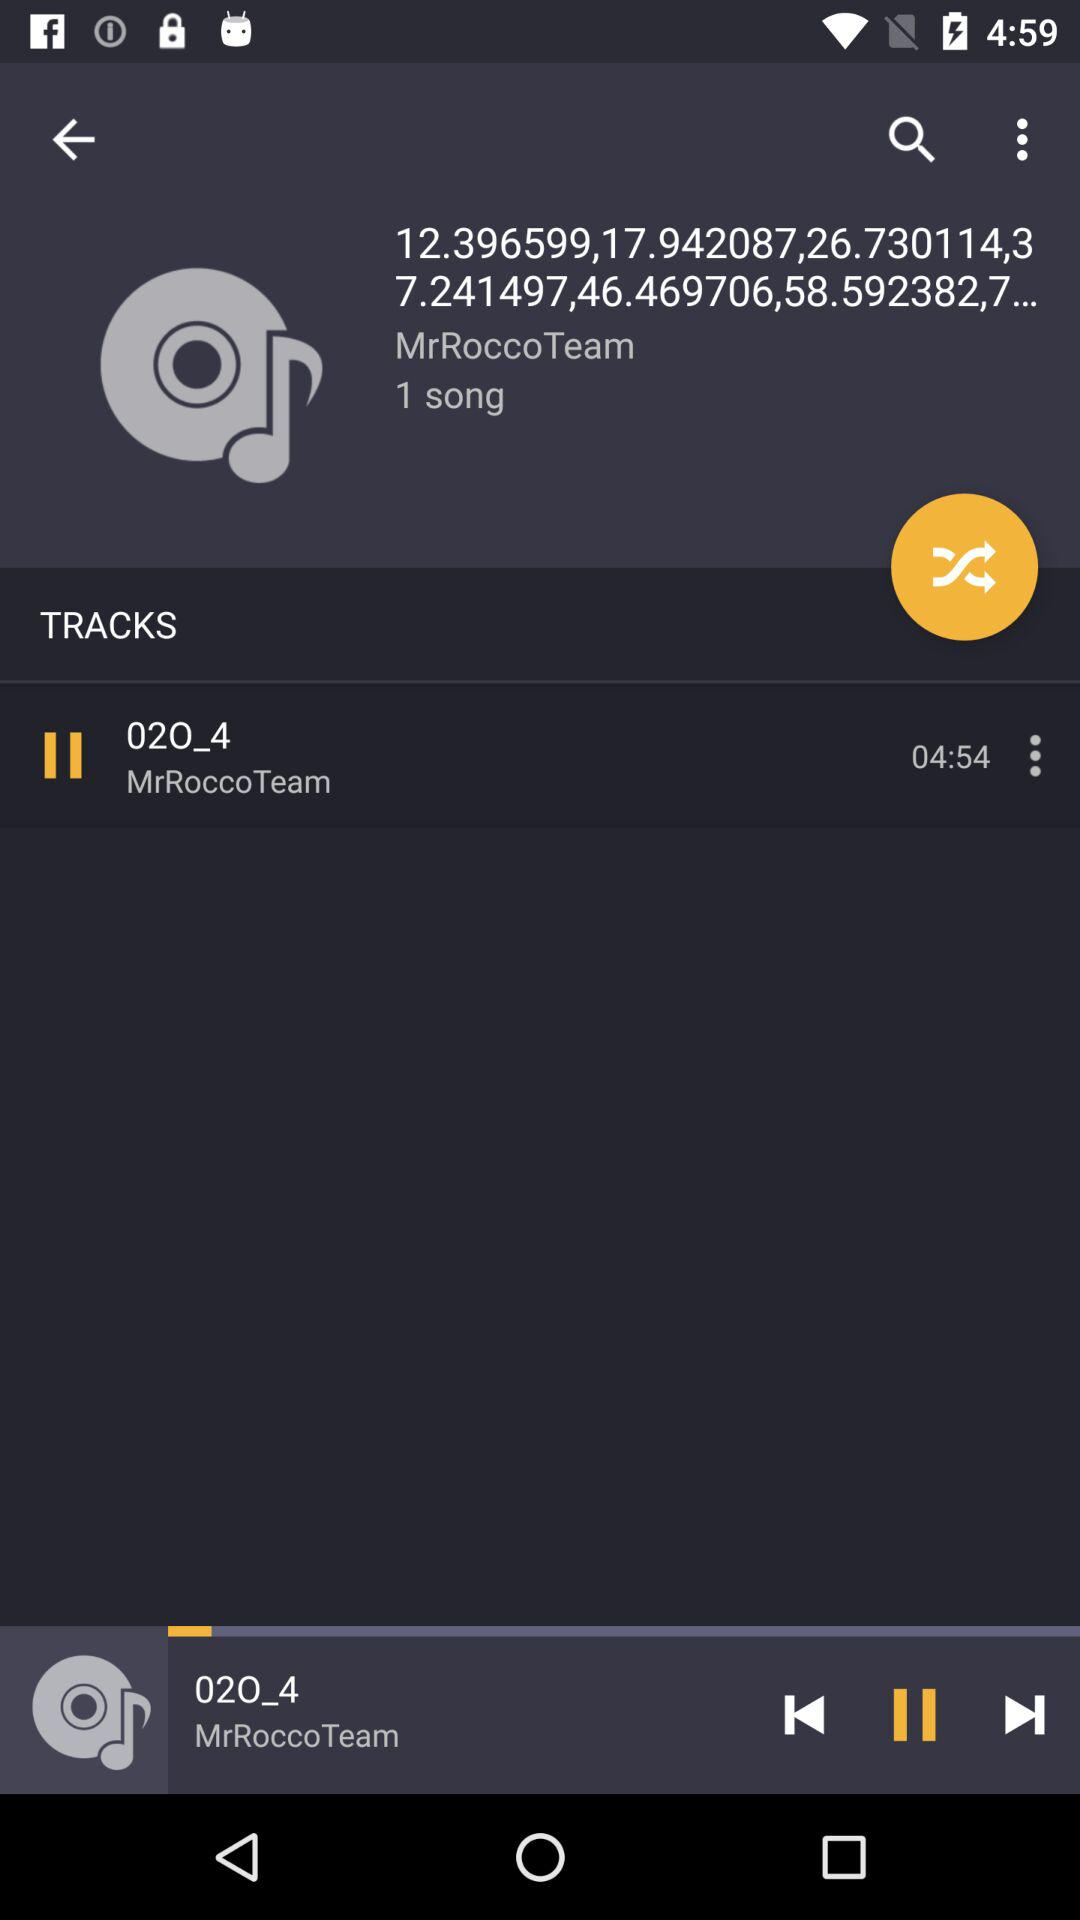How many songs are there by "MrRoccoTeam"? There is 1 song by "MrRoccoTeam". 